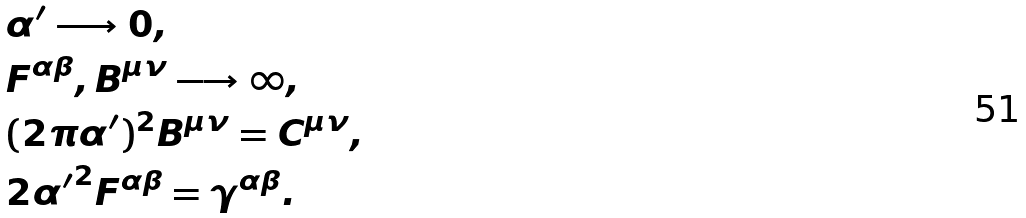<formula> <loc_0><loc_0><loc_500><loc_500>& \alpha ^ { \prime } \longrightarrow 0 , \\ & F ^ { \alpha \beta } , B ^ { \mu \nu } \longrightarrow \infty , \\ & ( 2 \pi \alpha ^ { \prime } ) ^ { 2 } B ^ { \mu \nu } = C ^ { \mu \nu } , \\ & 2 { \alpha ^ { \prime } } ^ { 2 } F ^ { \alpha \beta } = \gamma ^ { \alpha \beta } .</formula> 